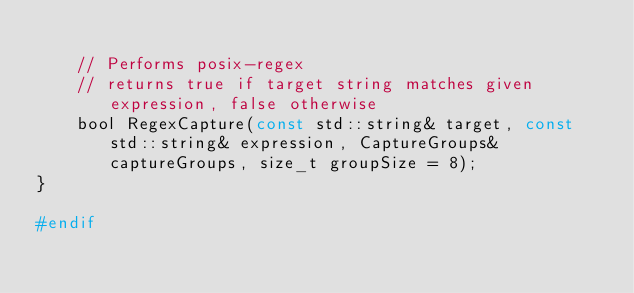<code> <loc_0><loc_0><loc_500><loc_500><_C_>
    // Performs posix-regex
    // returns true if target string matches given expression, false otherwise
    bool RegexCapture(const std::string& target, const std::string& expression, CaptureGroups& captureGroups, size_t groupSize = 8);
}

#endif
</code> 